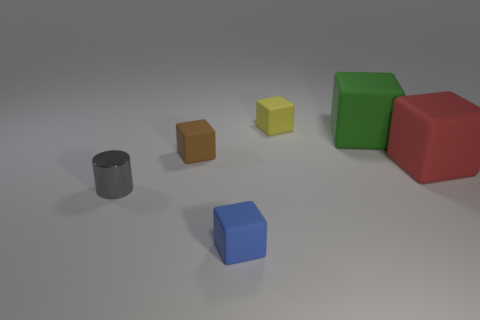Does the rubber object that is in front of the big red matte block have the same size as the rubber thing that is to the left of the tiny blue matte cube?
Offer a terse response. Yes. There is a gray thing in front of the block to the right of the green matte block; what is its shape?
Offer a terse response. Cylinder. Are there the same number of tiny metallic cylinders behind the green cube and blue cubes?
Offer a very short reply. No. What is the big block that is behind the rubber cube to the left of the tiny matte block that is in front of the gray metal cylinder made of?
Your answer should be very brief. Rubber. Is there a cylinder that has the same size as the green block?
Ensure brevity in your answer.  No. What shape is the tiny yellow thing?
Offer a very short reply. Cube. What number of balls are either tiny rubber objects or brown rubber objects?
Provide a succinct answer. 0. Are there the same number of red blocks that are in front of the small blue cube and cylinders that are in front of the gray metallic thing?
Make the answer very short. Yes. What number of yellow objects are behind the matte object in front of the big object in front of the big green thing?
Make the answer very short. 1. There is a small metal thing; is its color the same as the large thing that is behind the small brown cube?
Provide a succinct answer. No. 